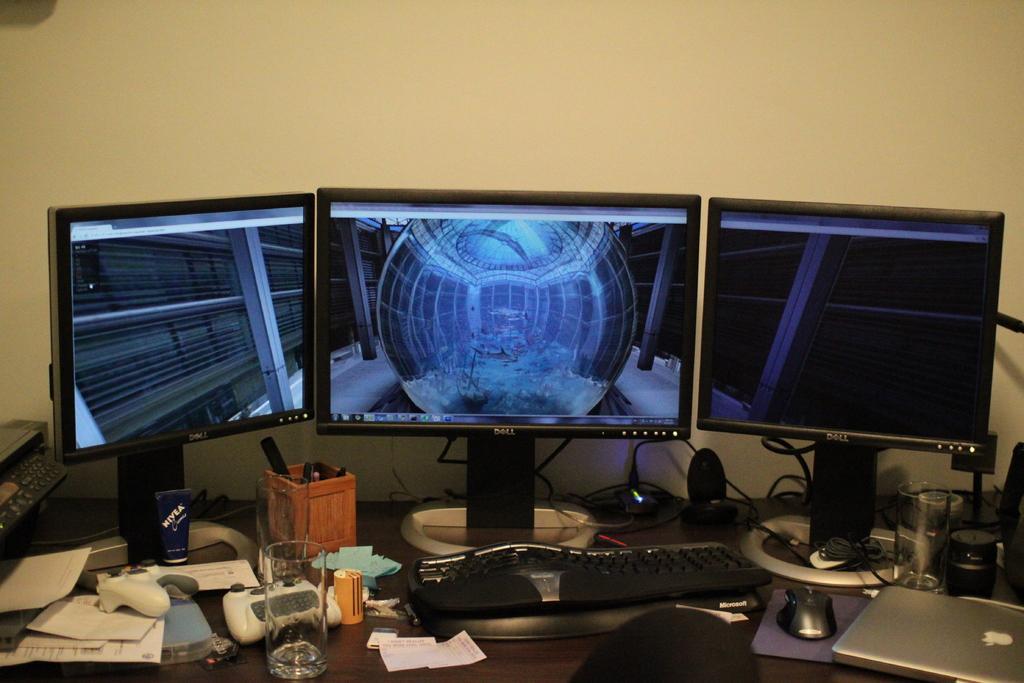In one or two sentences, can you explain what this image depicts? In the image we can see there is table on which there are three monitors, there is a pen stand, video player controller remote, glass, paper slips, keyboard, mouse, laptop and glass of water. 